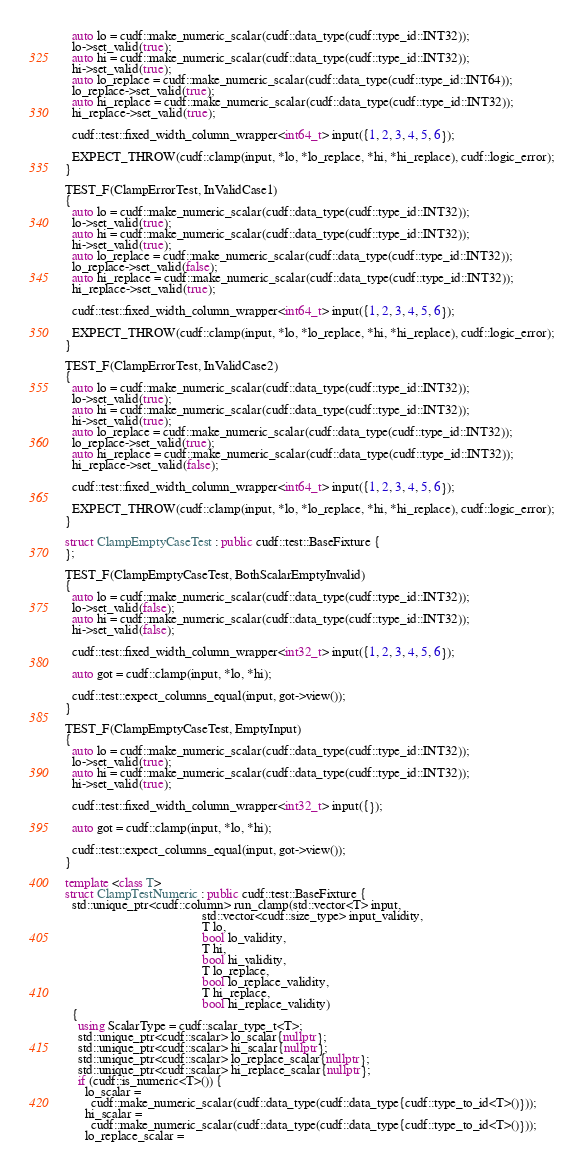Convert code to text. <code><loc_0><loc_0><loc_500><loc_500><_C++_>  auto lo = cudf::make_numeric_scalar(cudf::data_type(cudf::type_id::INT32));
  lo->set_valid(true);
  auto hi = cudf::make_numeric_scalar(cudf::data_type(cudf::type_id::INT32));
  hi->set_valid(true);
  auto lo_replace = cudf::make_numeric_scalar(cudf::data_type(cudf::type_id::INT64));
  lo_replace->set_valid(true);
  auto hi_replace = cudf::make_numeric_scalar(cudf::data_type(cudf::type_id::INT32));
  hi_replace->set_valid(true);

  cudf::test::fixed_width_column_wrapper<int64_t> input({1, 2, 3, 4, 5, 6});

  EXPECT_THROW(cudf::clamp(input, *lo, *lo_replace, *hi, *hi_replace), cudf::logic_error);
}

TEST_F(ClampErrorTest, InValidCase1)
{
  auto lo = cudf::make_numeric_scalar(cudf::data_type(cudf::type_id::INT32));
  lo->set_valid(true);
  auto hi = cudf::make_numeric_scalar(cudf::data_type(cudf::type_id::INT32));
  hi->set_valid(true);
  auto lo_replace = cudf::make_numeric_scalar(cudf::data_type(cudf::type_id::INT32));
  lo_replace->set_valid(false);
  auto hi_replace = cudf::make_numeric_scalar(cudf::data_type(cudf::type_id::INT32));
  hi_replace->set_valid(true);

  cudf::test::fixed_width_column_wrapper<int64_t> input({1, 2, 3, 4, 5, 6});

  EXPECT_THROW(cudf::clamp(input, *lo, *lo_replace, *hi, *hi_replace), cudf::logic_error);
}

TEST_F(ClampErrorTest, InValidCase2)
{
  auto lo = cudf::make_numeric_scalar(cudf::data_type(cudf::type_id::INT32));
  lo->set_valid(true);
  auto hi = cudf::make_numeric_scalar(cudf::data_type(cudf::type_id::INT32));
  hi->set_valid(true);
  auto lo_replace = cudf::make_numeric_scalar(cudf::data_type(cudf::type_id::INT32));
  lo_replace->set_valid(true);
  auto hi_replace = cudf::make_numeric_scalar(cudf::data_type(cudf::type_id::INT32));
  hi_replace->set_valid(false);

  cudf::test::fixed_width_column_wrapper<int64_t> input({1, 2, 3, 4, 5, 6});

  EXPECT_THROW(cudf::clamp(input, *lo, *lo_replace, *hi, *hi_replace), cudf::logic_error);
}

struct ClampEmptyCaseTest : public cudf::test::BaseFixture {
};

TEST_F(ClampEmptyCaseTest, BothScalarEmptyInvalid)
{
  auto lo = cudf::make_numeric_scalar(cudf::data_type(cudf::type_id::INT32));
  lo->set_valid(false);
  auto hi = cudf::make_numeric_scalar(cudf::data_type(cudf::type_id::INT32));
  hi->set_valid(false);

  cudf::test::fixed_width_column_wrapper<int32_t> input({1, 2, 3, 4, 5, 6});

  auto got = cudf::clamp(input, *lo, *hi);

  cudf::test::expect_columns_equal(input, got->view());
}

TEST_F(ClampEmptyCaseTest, EmptyInput)
{
  auto lo = cudf::make_numeric_scalar(cudf::data_type(cudf::type_id::INT32));
  lo->set_valid(true);
  auto hi = cudf::make_numeric_scalar(cudf::data_type(cudf::type_id::INT32));
  hi->set_valid(true);

  cudf::test::fixed_width_column_wrapper<int32_t> input({});

  auto got = cudf::clamp(input, *lo, *hi);

  cudf::test::expect_columns_equal(input, got->view());
}

template <class T>
struct ClampTestNumeric : public cudf::test::BaseFixture {
  std::unique_ptr<cudf::column> run_clamp(std::vector<T> input,
                                          std::vector<cudf::size_type> input_validity,
                                          T lo,
                                          bool lo_validity,
                                          T hi,
                                          bool hi_validity,
                                          T lo_replace,
                                          bool lo_replace_validity,
                                          T hi_replace,
                                          bool hi_replace_validity)
  {
    using ScalarType = cudf::scalar_type_t<T>;
    std::unique_ptr<cudf::scalar> lo_scalar{nullptr};
    std::unique_ptr<cudf::scalar> hi_scalar{nullptr};
    std::unique_ptr<cudf::scalar> lo_replace_scalar{nullptr};
    std::unique_ptr<cudf::scalar> hi_replace_scalar{nullptr};
    if (cudf::is_numeric<T>()) {
      lo_scalar =
        cudf::make_numeric_scalar(cudf::data_type(cudf::data_type{cudf::type_to_id<T>()}));
      hi_scalar =
        cudf::make_numeric_scalar(cudf::data_type(cudf::data_type{cudf::type_to_id<T>()}));
      lo_replace_scalar =</code> 